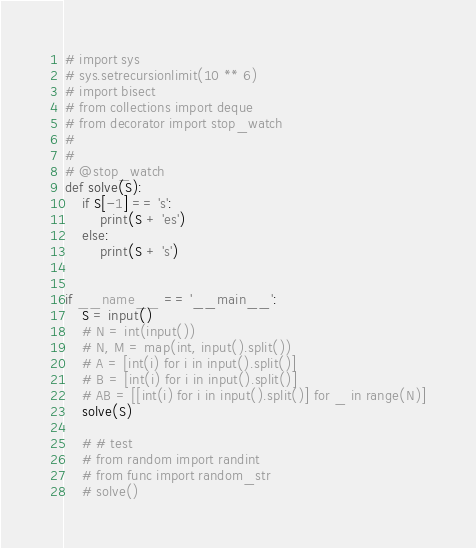<code> <loc_0><loc_0><loc_500><loc_500><_Python_># import sys
# sys.setrecursionlimit(10 ** 6)
# import bisect
# from collections import deque
# from decorator import stop_watch
# 
# 
# @stop_watch
def solve(S):
    if S[-1] == 's':
        print(S + 'es')
    else:
        print(S + 's')


if __name__ == '__main__':
    S = input()
    # N = int(input())
    # N, M = map(int, input().split())
    # A = [int(i) for i in input().split()]
    # B = [int(i) for i in input().split()]
    # AB = [[int(i) for i in input().split()] for _ in range(N)]
    solve(S)

    # # test
    # from random import randint
    # from func import random_str
    # solve()
</code> 